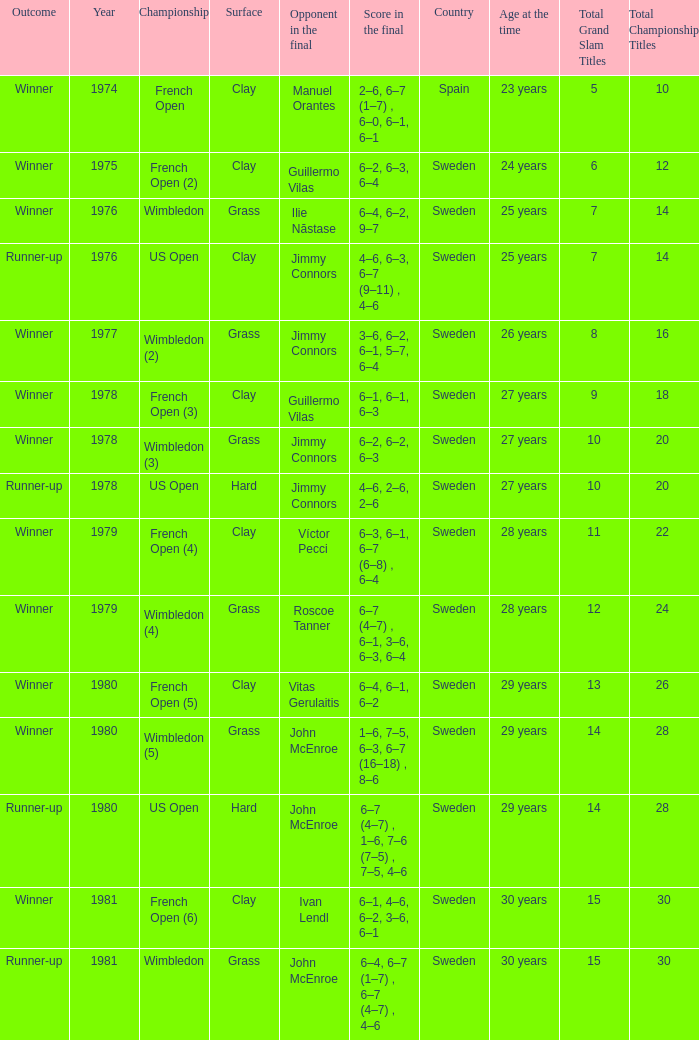What is every score in the final for opponent in final John Mcenroe at US Open? 6–7 (4–7) , 1–6, 7–6 (7–5) , 7–5, 4–6. 